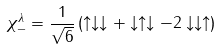<formula> <loc_0><loc_0><loc_500><loc_500>\chi ^ { \lambda } _ { - } = \frac { 1 } { \sqrt { 6 } } \left ( \uparrow \downarrow \downarrow + \downarrow \uparrow \downarrow - 2 \downarrow \downarrow \uparrow \right )</formula> 